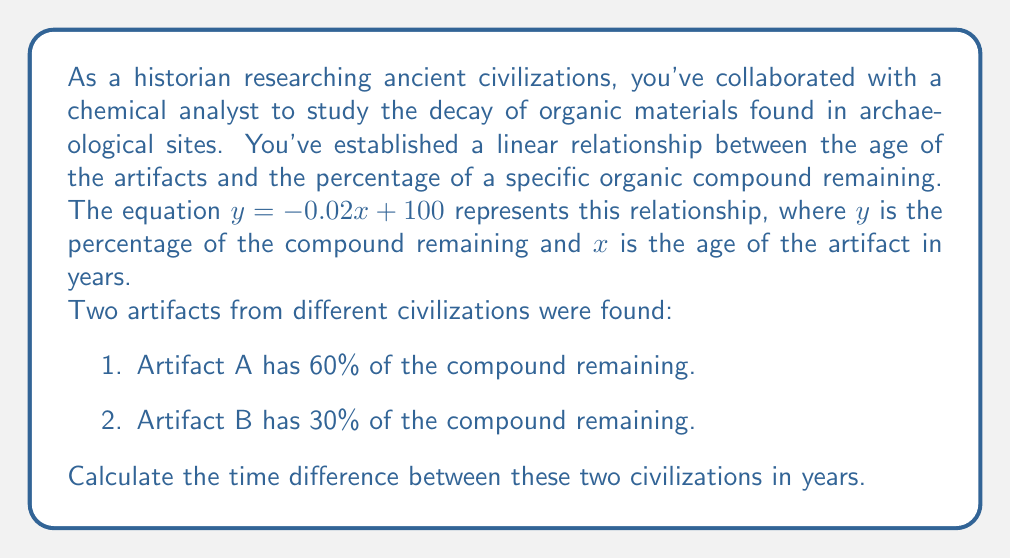Can you solve this math problem? To solve this problem, we need to follow these steps:

1. Find the age of Artifact A:
   Let $x_A$ be the age of Artifact A in years.
   $60 = -0.02x_A + 100$
   $-40 = -0.02x_A$
   $x_A = 2000$ years

2. Find the age of Artifact B:
   Let $x_B$ be the age of Artifact B in years.
   $30 = -0.02x_B + 100$
   $-70 = -0.02x_B$
   $x_B = 3500$ years

3. Calculate the time difference:
   Time difference = Age of Artifact B - Age of Artifact A
   $= 3500 - 2000 = 1500$ years

Therefore, the time difference between the two civilizations is 1500 years.
Answer: 1500 years 